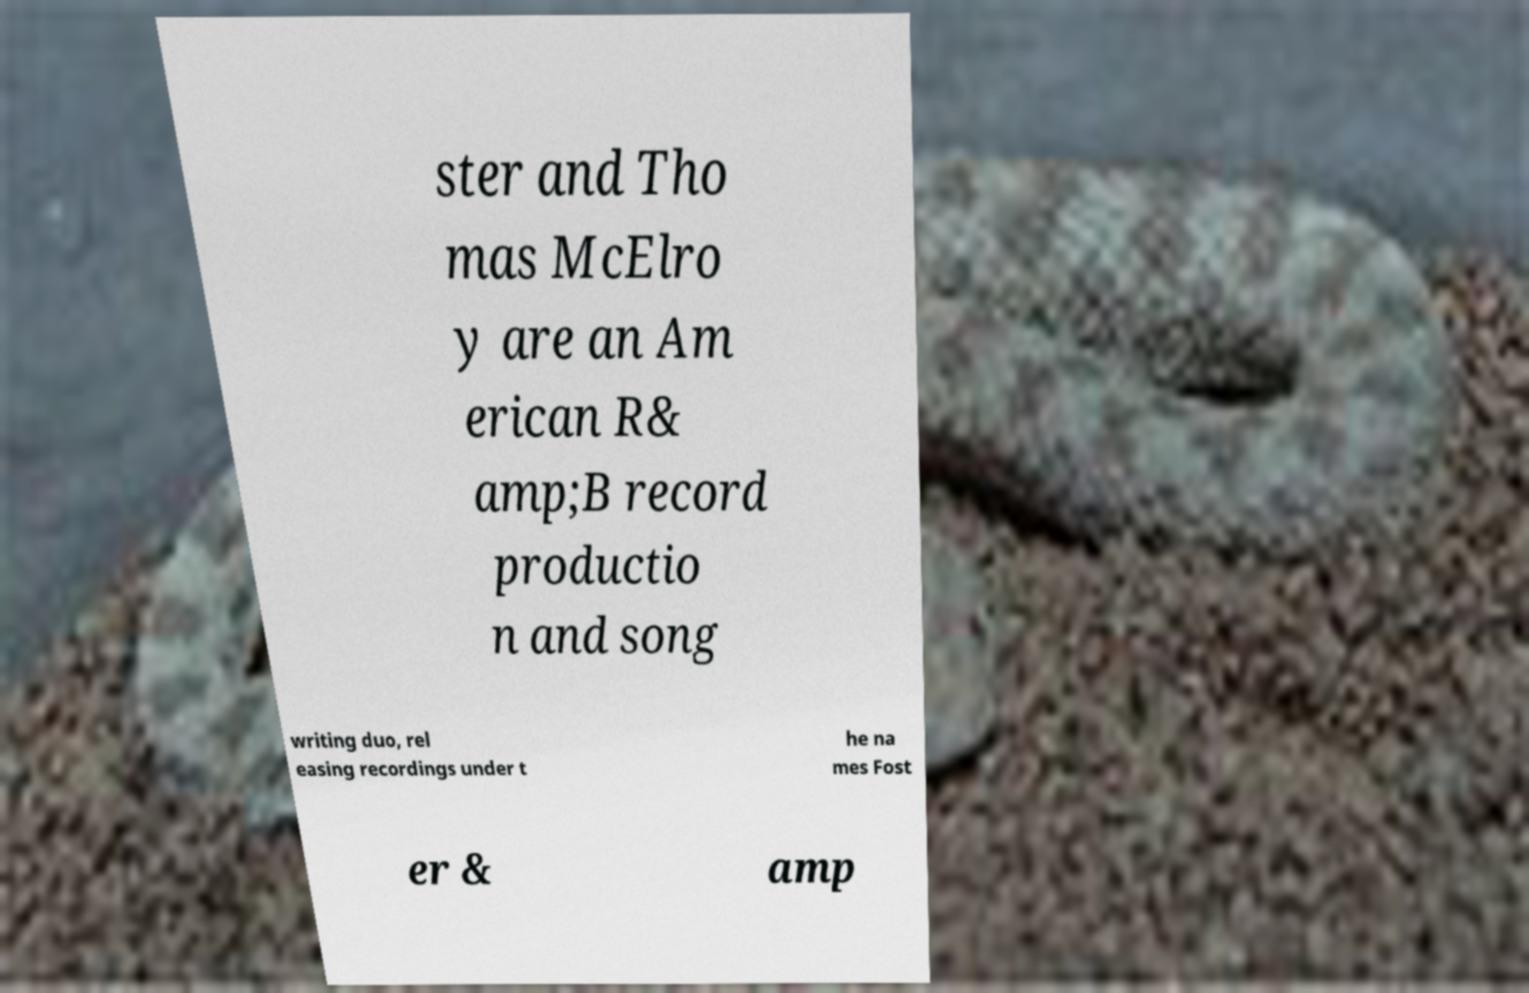Please read and relay the text visible in this image. What does it say? ster and Tho mas McElro y are an Am erican R& amp;B record productio n and song writing duo, rel easing recordings under t he na mes Fost er & amp 